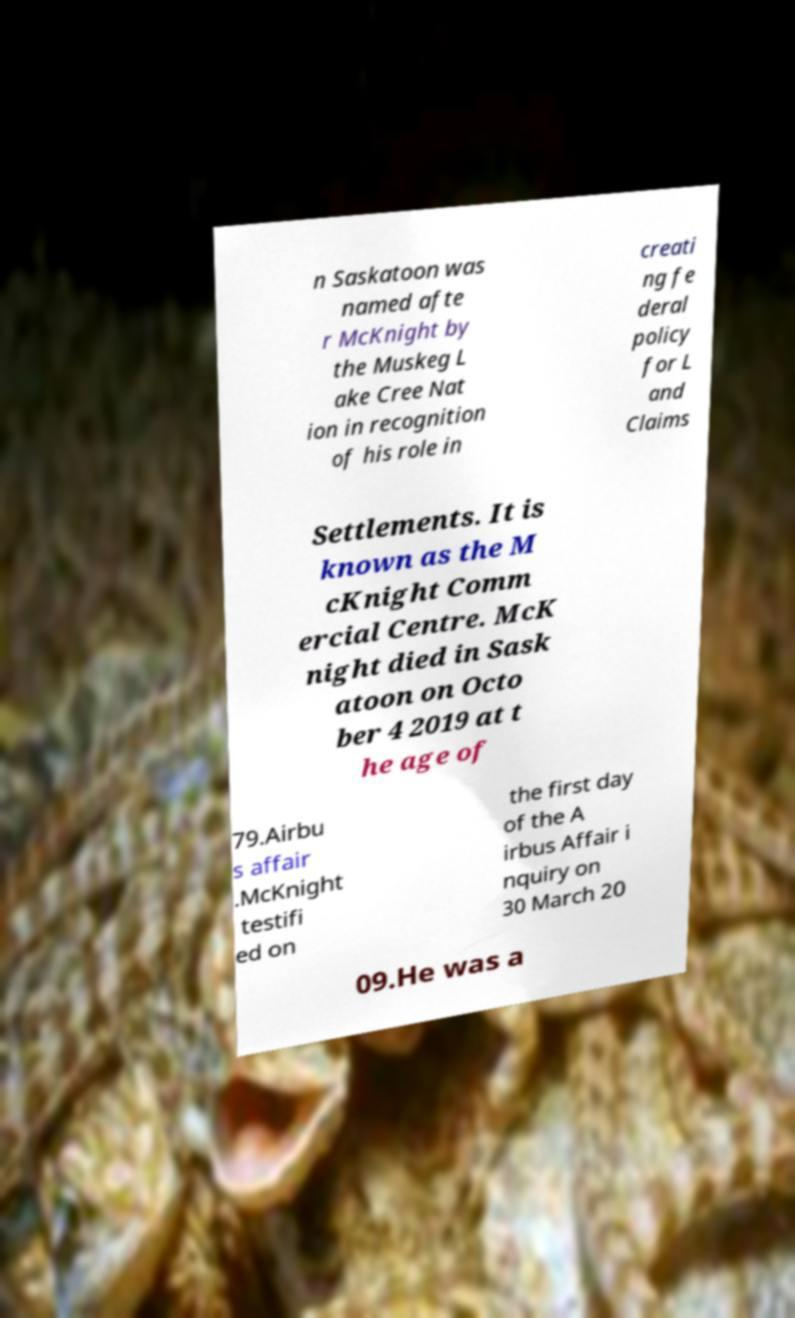Please read and relay the text visible in this image. What does it say? n Saskatoon was named afte r McKnight by the Muskeg L ake Cree Nat ion in recognition of his role in creati ng fe deral policy for L and Claims Settlements. It is known as the M cKnight Comm ercial Centre. McK night died in Sask atoon on Octo ber 4 2019 at t he age of 79.Airbu s affair .McKnight testifi ed on the first day of the A irbus Affair i nquiry on 30 March 20 09.He was a 